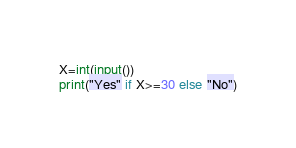<code> <loc_0><loc_0><loc_500><loc_500><_Python_>X=int(input())
print("Yes" if X>=30 else "No")</code> 